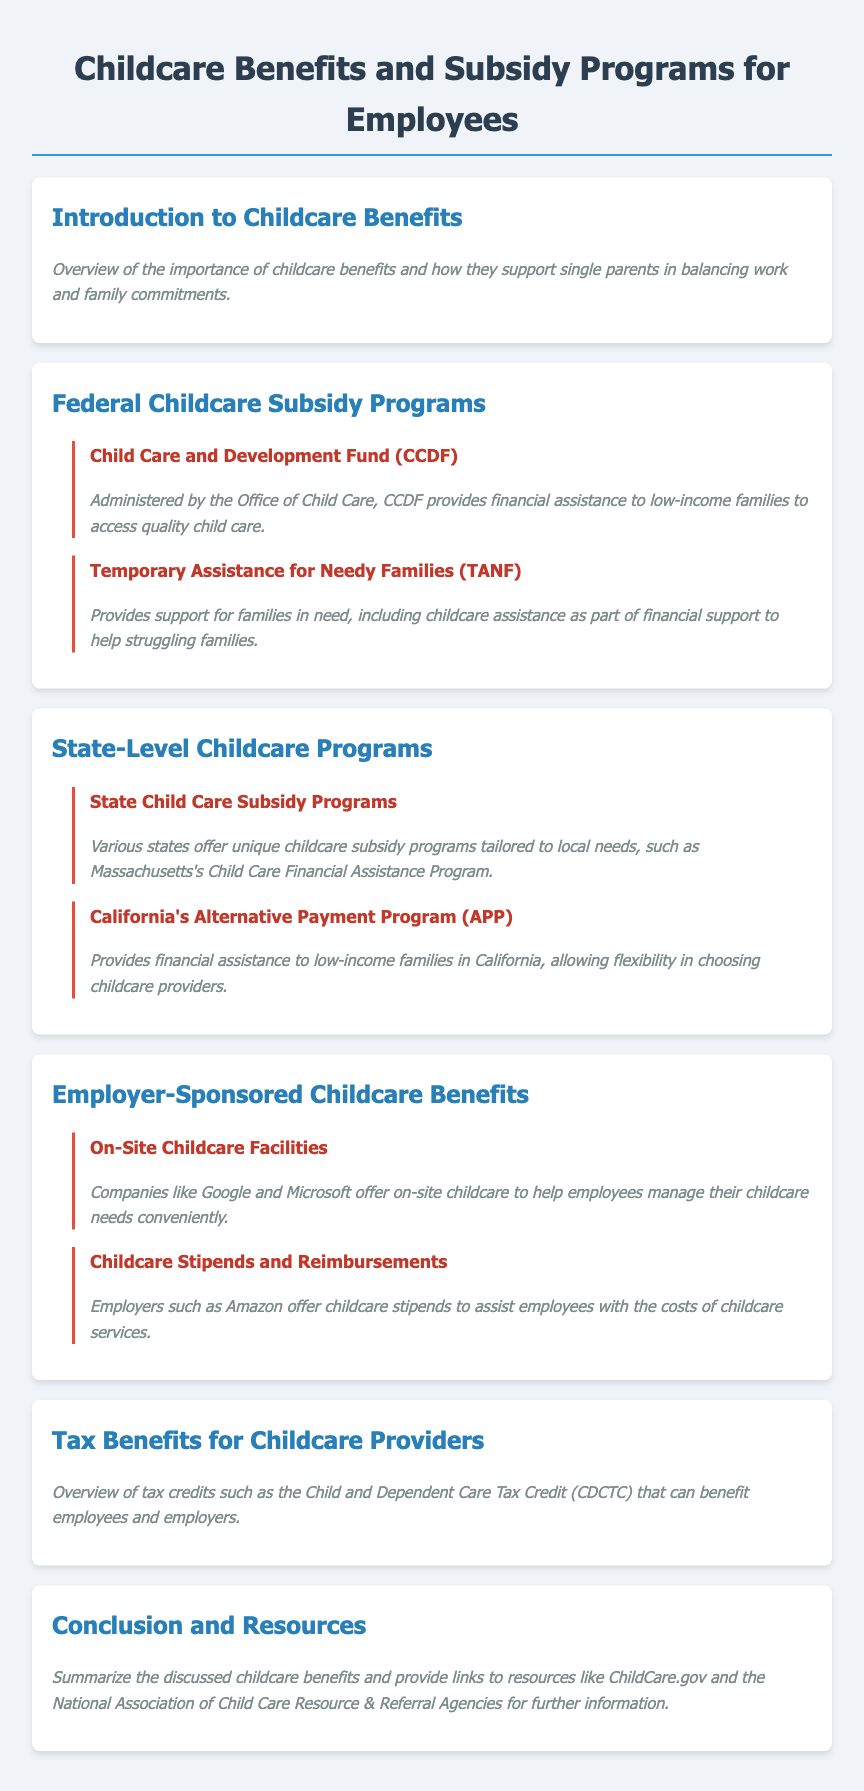What is the goal of childcare benefits? Childcare benefits support single parents in balancing work and family commitments.
Answer: Balancing work and family commitments What fund provides financial assistance to low-income families for quality child care? The Child Care and Development Fund (CCDF) is specifically designed for this purpose.
Answer: Child Care and Development Fund (CCDF) Which program is part of financial support for struggling families? The Temporary Assistance for Needy Families (TANF) helps provide this support.
Answer: Temporary Assistance for Needy Families (TANF) What is one example of a state-level childcare program? Massachusetts's Child Care Financial Assistance Program is a specific example of a state-level program.
Answer: Massachusetts's Child Care Financial Assistance Program What do companies like Google and Microsoft offer? They provide on-site childcare facilities to assist their employees.
Answer: On-site childcare facilities What type of employer-sponsored benefit helps with the costs of childcare services? Childcare stipends and reimbursements are offered by some employers for this purpose.
Answer: Childcare stipends and reimbursements What tax credit can benefit employees and employers? The Child and Dependent Care Tax Credit (CDCTC) is mentioned as a beneficial tax credit.
Answer: Child and Dependent Care Tax Credit (CDCTC) What is highlighted as a resource for further information? ChildCare.gov is listed as one of the resources for additional support.
Answer: ChildCare.gov 